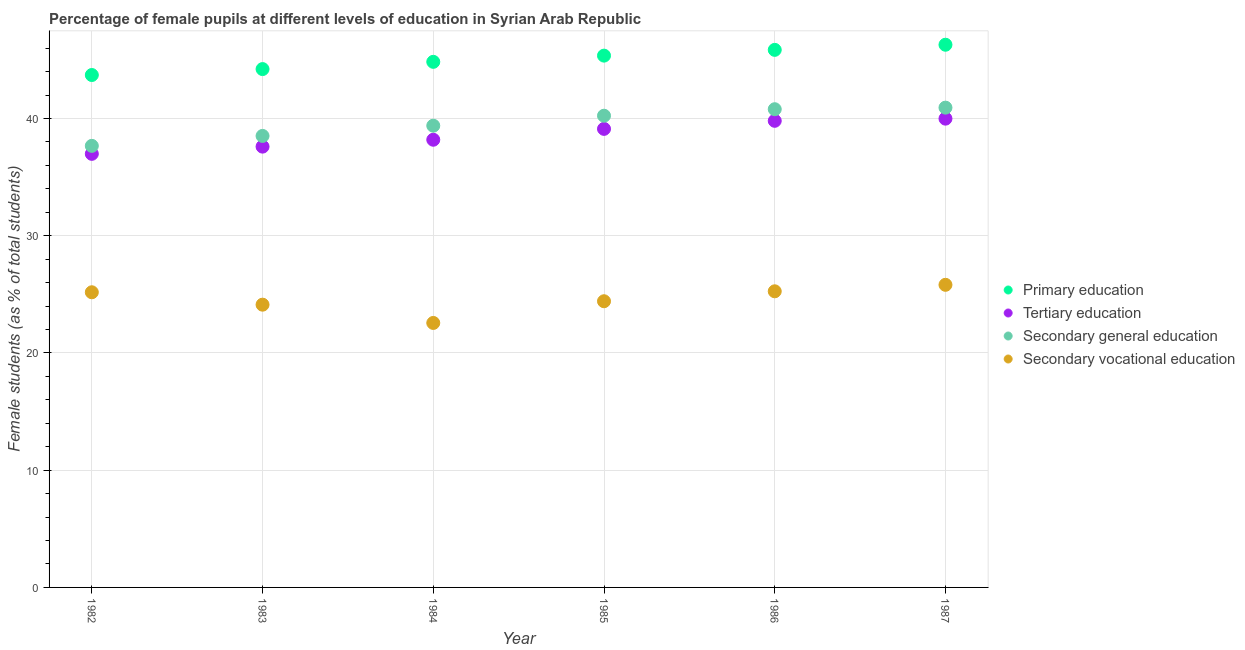Is the number of dotlines equal to the number of legend labels?
Your answer should be very brief. Yes. What is the percentage of female students in tertiary education in 1987?
Give a very brief answer. 39.99. Across all years, what is the maximum percentage of female students in primary education?
Your answer should be very brief. 46.3. Across all years, what is the minimum percentage of female students in secondary education?
Keep it short and to the point. 37.67. In which year was the percentage of female students in primary education maximum?
Provide a succinct answer. 1987. What is the total percentage of female students in secondary vocational education in the graph?
Your answer should be compact. 147.36. What is the difference between the percentage of female students in secondary vocational education in 1982 and that in 1986?
Your answer should be compact. -0.08. What is the difference between the percentage of female students in primary education in 1983 and the percentage of female students in secondary education in 1984?
Your response must be concise. 4.83. What is the average percentage of female students in secondary education per year?
Keep it short and to the point. 39.59. In the year 1985, what is the difference between the percentage of female students in tertiary education and percentage of female students in secondary education?
Give a very brief answer. -1.12. What is the ratio of the percentage of female students in primary education in 1984 to that in 1987?
Your response must be concise. 0.97. Is the percentage of female students in primary education in 1983 less than that in 1986?
Make the answer very short. Yes. Is the difference between the percentage of female students in secondary education in 1982 and 1985 greater than the difference between the percentage of female students in primary education in 1982 and 1985?
Make the answer very short. No. What is the difference between the highest and the second highest percentage of female students in secondary vocational education?
Provide a short and direct response. 0.55. What is the difference between the highest and the lowest percentage of female students in primary education?
Give a very brief answer. 2.58. Is the sum of the percentage of female students in secondary education in 1984 and 1985 greater than the maximum percentage of female students in tertiary education across all years?
Offer a very short reply. Yes. Is it the case that in every year, the sum of the percentage of female students in primary education and percentage of female students in secondary vocational education is greater than the sum of percentage of female students in secondary education and percentage of female students in tertiary education?
Offer a terse response. No. Is it the case that in every year, the sum of the percentage of female students in primary education and percentage of female students in tertiary education is greater than the percentage of female students in secondary education?
Provide a succinct answer. Yes. Does the percentage of female students in tertiary education monotonically increase over the years?
Give a very brief answer. Yes. How many dotlines are there?
Offer a very short reply. 4. How many years are there in the graph?
Offer a very short reply. 6. Does the graph contain grids?
Provide a succinct answer. Yes. How many legend labels are there?
Your answer should be compact. 4. What is the title of the graph?
Make the answer very short. Percentage of female pupils at different levels of education in Syrian Arab Republic. What is the label or title of the Y-axis?
Provide a succinct answer. Female students (as % of total students). What is the Female students (as % of total students) of Primary education in 1982?
Provide a succinct answer. 43.71. What is the Female students (as % of total students) in Tertiary education in 1982?
Your answer should be compact. 36.99. What is the Female students (as % of total students) of Secondary general education in 1982?
Your answer should be very brief. 37.67. What is the Female students (as % of total students) in Secondary vocational education in 1982?
Keep it short and to the point. 25.18. What is the Female students (as % of total students) of Primary education in 1983?
Your answer should be very brief. 44.22. What is the Female students (as % of total students) in Tertiary education in 1983?
Ensure brevity in your answer.  37.6. What is the Female students (as % of total students) in Secondary general education in 1983?
Offer a terse response. 38.52. What is the Female students (as % of total students) of Secondary vocational education in 1983?
Give a very brief answer. 24.12. What is the Female students (as % of total students) of Primary education in 1984?
Your response must be concise. 44.84. What is the Female students (as % of total students) of Tertiary education in 1984?
Your response must be concise. 38.19. What is the Female students (as % of total students) of Secondary general education in 1984?
Give a very brief answer. 39.39. What is the Female students (as % of total students) of Secondary vocational education in 1984?
Your answer should be very brief. 22.56. What is the Female students (as % of total students) of Primary education in 1985?
Your response must be concise. 45.37. What is the Female students (as % of total students) of Tertiary education in 1985?
Your answer should be very brief. 39.12. What is the Female students (as % of total students) in Secondary general education in 1985?
Keep it short and to the point. 40.24. What is the Female students (as % of total students) in Secondary vocational education in 1985?
Ensure brevity in your answer.  24.41. What is the Female students (as % of total students) in Primary education in 1986?
Provide a short and direct response. 45.86. What is the Female students (as % of total students) in Tertiary education in 1986?
Provide a succinct answer. 39.81. What is the Female students (as % of total students) of Secondary general education in 1986?
Offer a terse response. 40.8. What is the Female students (as % of total students) of Secondary vocational education in 1986?
Keep it short and to the point. 25.26. What is the Female students (as % of total students) in Primary education in 1987?
Your answer should be compact. 46.3. What is the Female students (as % of total students) in Tertiary education in 1987?
Provide a succinct answer. 39.99. What is the Female students (as % of total students) in Secondary general education in 1987?
Your answer should be compact. 40.93. What is the Female students (as % of total students) of Secondary vocational education in 1987?
Make the answer very short. 25.82. Across all years, what is the maximum Female students (as % of total students) in Primary education?
Ensure brevity in your answer.  46.3. Across all years, what is the maximum Female students (as % of total students) of Tertiary education?
Offer a terse response. 39.99. Across all years, what is the maximum Female students (as % of total students) in Secondary general education?
Provide a succinct answer. 40.93. Across all years, what is the maximum Female students (as % of total students) in Secondary vocational education?
Give a very brief answer. 25.82. Across all years, what is the minimum Female students (as % of total students) of Primary education?
Give a very brief answer. 43.71. Across all years, what is the minimum Female students (as % of total students) of Tertiary education?
Offer a terse response. 36.99. Across all years, what is the minimum Female students (as % of total students) of Secondary general education?
Provide a short and direct response. 37.67. Across all years, what is the minimum Female students (as % of total students) in Secondary vocational education?
Offer a terse response. 22.56. What is the total Female students (as % of total students) in Primary education in the graph?
Your answer should be compact. 270.29. What is the total Female students (as % of total students) in Tertiary education in the graph?
Your answer should be very brief. 231.7. What is the total Female students (as % of total students) of Secondary general education in the graph?
Give a very brief answer. 237.54. What is the total Female students (as % of total students) of Secondary vocational education in the graph?
Offer a terse response. 147.36. What is the difference between the Female students (as % of total students) of Primary education in 1982 and that in 1983?
Give a very brief answer. -0.51. What is the difference between the Female students (as % of total students) in Tertiary education in 1982 and that in 1983?
Offer a terse response. -0.62. What is the difference between the Female students (as % of total students) of Secondary general education in 1982 and that in 1983?
Offer a terse response. -0.85. What is the difference between the Female students (as % of total students) of Secondary vocational education in 1982 and that in 1983?
Provide a succinct answer. 1.06. What is the difference between the Female students (as % of total students) in Primary education in 1982 and that in 1984?
Your response must be concise. -1.12. What is the difference between the Female students (as % of total students) of Tertiary education in 1982 and that in 1984?
Offer a terse response. -1.2. What is the difference between the Female students (as % of total students) in Secondary general education in 1982 and that in 1984?
Your answer should be very brief. -1.72. What is the difference between the Female students (as % of total students) of Secondary vocational education in 1982 and that in 1984?
Make the answer very short. 2.62. What is the difference between the Female students (as % of total students) of Primary education in 1982 and that in 1985?
Provide a short and direct response. -1.65. What is the difference between the Female students (as % of total students) of Tertiary education in 1982 and that in 1985?
Your answer should be very brief. -2.13. What is the difference between the Female students (as % of total students) of Secondary general education in 1982 and that in 1985?
Offer a very short reply. -2.57. What is the difference between the Female students (as % of total students) of Secondary vocational education in 1982 and that in 1985?
Your answer should be very brief. 0.77. What is the difference between the Female students (as % of total students) of Primary education in 1982 and that in 1986?
Provide a short and direct response. -2.15. What is the difference between the Female students (as % of total students) of Tertiary education in 1982 and that in 1986?
Your answer should be compact. -2.82. What is the difference between the Female students (as % of total students) in Secondary general education in 1982 and that in 1986?
Offer a terse response. -3.13. What is the difference between the Female students (as % of total students) of Secondary vocational education in 1982 and that in 1986?
Provide a succinct answer. -0.08. What is the difference between the Female students (as % of total students) of Primary education in 1982 and that in 1987?
Provide a short and direct response. -2.58. What is the difference between the Female students (as % of total students) in Tertiary education in 1982 and that in 1987?
Offer a very short reply. -3. What is the difference between the Female students (as % of total students) in Secondary general education in 1982 and that in 1987?
Keep it short and to the point. -3.26. What is the difference between the Female students (as % of total students) in Secondary vocational education in 1982 and that in 1987?
Offer a very short reply. -0.64. What is the difference between the Female students (as % of total students) of Primary education in 1983 and that in 1984?
Give a very brief answer. -0.62. What is the difference between the Female students (as % of total students) in Tertiary education in 1983 and that in 1984?
Provide a succinct answer. -0.59. What is the difference between the Female students (as % of total students) in Secondary general education in 1983 and that in 1984?
Provide a short and direct response. -0.87. What is the difference between the Female students (as % of total students) in Secondary vocational education in 1983 and that in 1984?
Make the answer very short. 1.56. What is the difference between the Female students (as % of total students) in Primary education in 1983 and that in 1985?
Your answer should be very brief. -1.15. What is the difference between the Female students (as % of total students) of Tertiary education in 1983 and that in 1985?
Your response must be concise. -1.51. What is the difference between the Female students (as % of total students) of Secondary general education in 1983 and that in 1985?
Your answer should be compact. -1.72. What is the difference between the Female students (as % of total students) of Secondary vocational education in 1983 and that in 1985?
Make the answer very short. -0.29. What is the difference between the Female students (as % of total students) of Primary education in 1983 and that in 1986?
Your answer should be compact. -1.64. What is the difference between the Female students (as % of total students) in Tertiary education in 1983 and that in 1986?
Give a very brief answer. -2.2. What is the difference between the Female students (as % of total students) of Secondary general education in 1983 and that in 1986?
Provide a succinct answer. -2.28. What is the difference between the Female students (as % of total students) of Secondary vocational education in 1983 and that in 1986?
Offer a terse response. -1.14. What is the difference between the Female students (as % of total students) in Primary education in 1983 and that in 1987?
Provide a succinct answer. -2.08. What is the difference between the Female students (as % of total students) in Tertiary education in 1983 and that in 1987?
Make the answer very short. -2.39. What is the difference between the Female students (as % of total students) of Secondary general education in 1983 and that in 1987?
Give a very brief answer. -2.41. What is the difference between the Female students (as % of total students) of Secondary vocational education in 1983 and that in 1987?
Give a very brief answer. -1.69. What is the difference between the Female students (as % of total students) of Primary education in 1984 and that in 1985?
Provide a succinct answer. -0.53. What is the difference between the Female students (as % of total students) of Tertiary education in 1984 and that in 1985?
Make the answer very short. -0.93. What is the difference between the Female students (as % of total students) in Secondary general education in 1984 and that in 1985?
Your answer should be compact. -0.85. What is the difference between the Female students (as % of total students) in Secondary vocational education in 1984 and that in 1985?
Provide a short and direct response. -1.85. What is the difference between the Female students (as % of total students) in Primary education in 1984 and that in 1986?
Your answer should be compact. -1.02. What is the difference between the Female students (as % of total students) in Tertiary education in 1984 and that in 1986?
Your response must be concise. -1.61. What is the difference between the Female students (as % of total students) in Secondary general education in 1984 and that in 1986?
Your answer should be very brief. -1.41. What is the difference between the Female students (as % of total students) of Secondary vocational education in 1984 and that in 1986?
Keep it short and to the point. -2.7. What is the difference between the Female students (as % of total students) in Primary education in 1984 and that in 1987?
Make the answer very short. -1.46. What is the difference between the Female students (as % of total students) of Tertiary education in 1984 and that in 1987?
Make the answer very short. -1.8. What is the difference between the Female students (as % of total students) of Secondary general education in 1984 and that in 1987?
Make the answer very short. -1.54. What is the difference between the Female students (as % of total students) in Secondary vocational education in 1984 and that in 1987?
Offer a very short reply. -3.25. What is the difference between the Female students (as % of total students) of Primary education in 1985 and that in 1986?
Your response must be concise. -0.49. What is the difference between the Female students (as % of total students) in Tertiary education in 1985 and that in 1986?
Provide a short and direct response. -0.69. What is the difference between the Female students (as % of total students) of Secondary general education in 1985 and that in 1986?
Offer a terse response. -0.55. What is the difference between the Female students (as % of total students) of Secondary vocational education in 1985 and that in 1986?
Keep it short and to the point. -0.85. What is the difference between the Female students (as % of total students) of Primary education in 1985 and that in 1987?
Your answer should be very brief. -0.93. What is the difference between the Female students (as % of total students) of Tertiary education in 1985 and that in 1987?
Keep it short and to the point. -0.87. What is the difference between the Female students (as % of total students) of Secondary general education in 1985 and that in 1987?
Provide a short and direct response. -0.69. What is the difference between the Female students (as % of total students) in Secondary vocational education in 1985 and that in 1987?
Ensure brevity in your answer.  -1.4. What is the difference between the Female students (as % of total students) in Primary education in 1986 and that in 1987?
Keep it short and to the point. -0.44. What is the difference between the Female students (as % of total students) in Tertiary education in 1986 and that in 1987?
Offer a very short reply. -0.18. What is the difference between the Female students (as % of total students) of Secondary general education in 1986 and that in 1987?
Keep it short and to the point. -0.13. What is the difference between the Female students (as % of total students) of Secondary vocational education in 1986 and that in 1987?
Provide a short and direct response. -0.55. What is the difference between the Female students (as % of total students) of Primary education in 1982 and the Female students (as % of total students) of Tertiary education in 1983?
Your answer should be compact. 6.11. What is the difference between the Female students (as % of total students) in Primary education in 1982 and the Female students (as % of total students) in Secondary general education in 1983?
Offer a very short reply. 5.2. What is the difference between the Female students (as % of total students) of Primary education in 1982 and the Female students (as % of total students) of Secondary vocational education in 1983?
Your answer should be compact. 19.59. What is the difference between the Female students (as % of total students) of Tertiary education in 1982 and the Female students (as % of total students) of Secondary general education in 1983?
Your answer should be very brief. -1.53. What is the difference between the Female students (as % of total students) in Tertiary education in 1982 and the Female students (as % of total students) in Secondary vocational education in 1983?
Provide a short and direct response. 12.87. What is the difference between the Female students (as % of total students) in Secondary general education in 1982 and the Female students (as % of total students) in Secondary vocational education in 1983?
Keep it short and to the point. 13.55. What is the difference between the Female students (as % of total students) in Primary education in 1982 and the Female students (as % of total students) in Tertiary education in 1984?
Provide a succinct answer. 5.52. What is the difference between the Female students (as % of total students) in Primary education in 1982 and the Female students (as % of total students) in Secondary general education in 1984?
Your answer should be very brief. 4.32. What is the difference between the Female students (as % of total students) in Primary education in 1982 and the Female students (as % of total students) in Secondary vocational education in 1984?
Provide a short and direct response. 21.15. What is the difference between the Female students (as % of total students) of Tertiary education in 1982 and the Female students (as % of total students) of Secondary general education in 1984?
Your answer should be very brief. -2.4. What is the difference between the Female students (as % of total students) in Tertiary education in 1982 and the Female students (as % of total students) in Secondary vocational education in 1984?
Make the answer very short. 14.43. What is the difference between the Female students (as % of total students) in Secondary general education in 1982 and the Female students (as % of total students) in Secondary vocational education in 1984?
Your response must be concise. 15.11. What is the difference between the Female students (as % of total students) of Primary education in 1982 and the Female students (as % of total students) of Tertiary education in 1985?
Ensure brevity in your answer.  4.6. What is the difference between the Female students (as % of total students) of Primary education in 1982 and the Female students (as % of total students) of Secondary general education in 1985?
Your answer should be very brief. 3.47. What is the difference between the Female students (as % of total students) of Primary education in 1982 and the Female students (as % of total students) of Secondary vocational education in 1985?
Your answer should be very brief. 19.3. What is the difference between the Female students (as % of total students) of Tertiary education in 1982 and the Female students (as % of total students) of Secondary general education in 1985?
Ensure brevity in your answer.  -3.25. What is the difference between the Female students (as % of total students) of Tertiary education in 1982 and the Female students (as % of total students) of Secondary vocational education in 1985?
Offer a very short reply. 12.57. What is the difference between the Female students (as % of total students) of Secondary general education in 1982 and the Female students (as % of total students) of Secondary vocational education in 1985?
Provide a succinct answer. 13.26. What is the difference between the Female students (as % of total students) of Primary education in 1982 and the Female students (as % of total students) of Tertiary education in 1986?
Offer a very short reply. 3.91. What is the difference between the Female students (as % of total students) in Primary education in 1982 and the Female students (as % of total students) in Secondary general education in 1986?
Keep it short and to the point. 2.92. What is the difference between the Female students (as % of total students) of Primary education in 1982 and the Female students (as % of total students) of Secondary vocational education in 1986?
Offer a very short reply. 18.45. What is the difference between the Female students (as % of total students) in Tertiary education in 1982 and the Female students (as % of total students) in Secondary general education in 1986?
Offer a terse response. -3.81. What is the difference between the Female students (as % of total students) in Tertiary education in 1982 and the Female students (as % of total students) in Secondary vocational education in 1986?
Offer a terse response. 11.73. What is the difference between the Female students (as % of total students) of Secondary general education in 1982 and the Female students (as % of total students) of Secondary vocational education in 1986?
Offer a terse response. 12.41. What is the difference between the Female students (as % of total students) of Primary education in 1982 and the Female students (as % of total students) of Tertiary education in 1987?
Make the answer very short. 3.72. What is the difference between the Female students (as % of total students) of Primary education in 1982 and the Female students (as % of total students) of Secondary general education in 1987?
Ensure brevity in your answer.  2.78. What is the difference between the Female students (as % of total students) of Primary education in 1982 and the Female students (as % of total students) of Secondary vocational education in 1987?
Provide a succinct answer. 17.9. What is the difference between the Female students (as % of total students) in Tertiary education in 1982 and the Female students (as % of total students) in Secondary general education in 1987?
Your response must be concise. -3.94. What is the difference between the Female students (as % of total students) of Tertiary education in 1982 and the Female students (as % of total students) of Secondary vocational education in 1987?
Keep it short and to the point. 11.17. What is the difference between the Female students (as % of total students) in Secondary general education in 1982 and the Female students (as % of total students) in Secondary vocational education in 1987?
Offer a very short reply. 11.85. What is the difference between the Female students (as % of total students) of Primary education in 1983 and the Female students (as % of total students) of Tertiary education in 1984?
Make the answer very short. 6.03. What is the difference between the Female students (as % of total students) of Primary education in 1983 and the Female students (as % of total students) of Secondary general education in 1984?
Provide a short and direct response. 4.83. What is the difference between the Female students (as % of total students) of Primary education in 1983 and the Female students (as % of total students) of Secondary vocational education in 1984?
Offer a very short reply. 21.66. What is the difference between the Female students (as % of total students) of Tertiary education in 1983 and the Female students (as % of total students) of Secondary general education in 1984?
Make the answer very short. -1.79. What is the difference between the Female students (as % of total students) of Tertiary education in 1983 and the Female students (as % of total students) of Secondary vocational education in 1984?
Offer a very short reply. 15.04. What is the difference between the Female students (as % of total students) in Secondary general education in 1983 and the Female students (as % of total students) in Secondary vocational education in 1984?
Make the answer very short. 15.95. What is the difference between the Female students (as % of total students) of Primary education in 1983 and the Female students (as % of total students) of Tertiary education in 1985?
Keep it short and to the point. 5.1. What is the difference between the Female students (as % of total students) in Primary education in 1983 and the Female students (as % of total students) in Secondary general education in 1985?
Offer a terse response. 3.98. What is the difference between the Female students (as % of total students) of Primary education in 1983 and the Female students (as % of total students) of Secondary vocational education in 1985?
Your answer should be very brief. 19.81. What is the difference between the Female students (as % of total students) of Tertiary education in 1983 and the Female students (as % of total students) of Secondary general education in 1985?
Your answer should be very brief. -2.64. What is the difference between the Female students (as % of total students) in Tertiary education in 1983 and the Female students (as % of total students) in Secondary vocational education in 1985?
Your response must be concise. 13.19. What is the difference between the Female students (as % of total students) in Secondary general education in 1983 and the Female students (as % of total students) in Secondary vocational education in 1985?
Your answer should be very brief. 14.1. What is the difference between the Female students (as % of total students) in Primary education in 1983 and the Female students (as % of total students) in Tertiary education in 1986?
Give a very brief answer. 4.41. What is the difference between the Female students (as % of total students) of Primary education in 1983 and the Female students (as % of total students) of Secondary general education in 1986?
Provide a succinct answer. 3.42. What is the difference between the Female students (as % of total students) of Primary education in 1983 and the Female students (as % of total students) of Secondary vocational education in 1986?
Offer a very short reply. 18.96. What is the difference between the Female students (as % of total students) in Tertiary education in 1983 and the Female students (as % of total students) in Secondary general education in 1986?
Offer a terse response. -3.19. What is the difference between the Female students (as % of total students) in Tertiary education in 1983 and the Female students (as % of total students) in Secondary vocational education in 1986?
Your answer should be very brief. 12.34. What is the difference between the Female students (as % of total students) in Secondary general education in 1983 and the Female students (as % of total students) in Secondary vocational education in 1986?
Offer a terse response. 13.25. What is the difference between the Female students (as % of total students) of Primary education in 1983 and the Female students (as % of total students) of Tertiary education in 1987?
Keep it short and to the point. 4.23. What is the difference between the Female students (as % of total students) of Primary education in 1983 and the Female students (as % of total students) of Secondary general education in 1987?
Your response must be concise. 3.29. What is the difference between the Female students (as % of total students) in Primary education in 1983 and the Female students (as % of total students) in Secondary vocational education in 1987?
Your response must be concise. 18.4. What is the difference between the Female students (as % of total students) of Tertiary education in 1983 and the Female students (as % of total students) of Secondary general education in 1987?
Give a very brief answer. -3.33. What is the difference between the Female students (as % of total students) of Tertiary education in 1983 and the Female students (as % of total students) of Secondary vocational education in 1987?
Ensure brevity in your answer.  11.79. What is the difference between the Female students (as % of total students) of Secondary general education in 1983 and the Female students (as % of total students) of Secondary vocational education in 1987?
Offer a terse response. 12.7. What is the difference between the Female students (as % of total students) in Primary education in 1984 and the Female students (as % of total students) in Tertiary education in 1985?
Offer a terse response. 5.72. What is the difference between the Female students (as % of total students) of Primary education in 1984 and the Female students (as % of total students) of Secondary general education in 1985?
Ensure brevity in your answer.  4.6. What is the difference between the Female students (as % of total students) of Primary education in 1984 and the Female students (as % of total students) of Secondary vocational education in 1985?
Your response must be concise. 20.42. What is the difference between the Female students (as % of total students) in Tertiary education in 1984 and the Female students (as % of total students) in Secondary general education in 1985?
Keep it short and to the point. -2.05. What is the difference between the Female students (as % of total students) in Tertiary education in 1984 and the Female students (as % of total students) in Secondary vocational education in 1985?
Give a very brief answer. 13.78. What is the difference between the Female students (as % of total students) of Secondary general education in 1984 and the Female students (as % of total students) of Secondary vocational education in 1985?
Your answer should be compact. 14.98. What is the difference between the Female students (as % of total students) in Primary education in 1984 and the Female students (as % of total students) in Tertiary education in 1986?
Offer a very short reply. 5.03. What is the difference between the Female students (as % of total students) of Primary education in 1984 and the Female students (as % of total students) of Secondary general education in 1986?
Provide a succinct answer. 4.04. What is the difference between the Female students (as % of total students) in Primary education in 1984 and the Female students (as % of total students) in Secondary vocational education in 1986?
Offer a terse response. 19.58. What is the difference between the Female students (as % of total students) in Tertiary education in 1984 and the Female students (as % of total students) in Secondary general education in 1986?
Offer a terse response. -2.6. What is the difference between the Female students (as % of total students) in Tertiary education in 1984 and the Female students (as % of total students) in Secondary vocational education in 1986?
Keep it short and to the point. 12.93. What is the difference between the Female students (as % of total students) in Secondary general education in 1984 and the Female students (as % of total students) in Secondary vocational education in 1986?
Provide a short and direct response. 14.13. What is the difference between the Female students (as % of total students) of Primary education in 1984 and the Female students (as % of total students) of Tertiary education in 1987?
Your answer should be compact. 4.85. What is the difference between the Female students (as % of total students) in Primary education in 1984 and the Female students (as % of total students) in Secondary general education in 1987?
Provide a short and direct response. 3.91. What is the difference between the Female students (as % of total students) in Primary education in 1984 and the Female students (as % of total students) in Secondary vocational education in 1987?
Make the answer very short. 19.02. What is the difference between the Female students (as % of total students) of Tertiary education in 1984 and the Female students (as % of total students) of Secondary general education in 1987?
Give a very brief answer. -2.74. What is the difference between the Female students (as % of total students) of Tertiary education in 1984 and the Female students (as % of total students) of Secondary vocational education in 1987?
Your answer should be very brief. 12.38. What is the difference between the Female students (as % of total students) in Secondary general education in 1984 and the Female students (as % of total students) in Secondary vocational education in 1987?
Your answer should be compact. 13.57. What is the difference between the Female students (as % of total students) in Primary education in 1985 and the Female students (as % of total students) in Tertiary education in 1986?
Offer a terse response. 5.56. What is the difference between the Female students (as % of total students) of Primary education in 1985 and the Female students (as % of total students) of Secondary general education in 1986?
Your response must be concise. 4.57. What is the difference between the Female students (as % of total students) of Primary education in 1985 and the Female students (as % of total students) of Secondary vocational education in 1986?
Your answer should be compact. 20.1. What is the difference between the Female students (as % of total students) of Tertiary education in 1985 and the Female students (as % of total students) of Secondary general education in 1986?
Give a very brief answer. -1.68. What is the difference between the Female students (as % of total students) of Tertiary education in 1985 and the Female students (as % of total students) of Secondary vocational education in 1986?
Your answer should be compact. 13.86. What is the difference between the Female students (as % of total students) in Secondary general education in 1985 and the Female students (as % of total students) in Secondary vocational education in 1986?
Provide a short and direct response. 14.98. What is the difference between the Female students (as % of total students) in Primary education in 1985 and the Female students (as % of total students) in Tertiary education in 1987?
Ensure brevity in your answer.  5.38. What is the difference between the Female students (as % of total students) of Primary education in 1985 and the Female students (as % of total students) of Secondary general education in 1987?
Provide a short and direct response. 4.44. What is the difference between the Female students (as % of total students) in Primary education in 1985 and the Female students (as % of total students) in Secondary vocational education in 1987?
Offer a very short reply. 19.55. What is the difference between the Female students (as % of total students) in Tertiary education in 1985 and the Female students (as % of total students) in Secondary general education in 1987?
Your response must be concise. -1.81. What is the difference between the Female students (as % of total students) of Tertiary education in 1985 and the Female students (as % of total students) of Secondary vocational education in 1987?
Your response must be concise. 13.3. What is the difference between the Female students (as % of total students) in Secondary general education in 1985 and the Female students (as % of total students) in Secondary vocational education in 1987?
Offer a terse response. 14.43. What is the difference between the Female students (as % of total students) in Primary education in 1986 and the Female students (as % of total students) in Tertiary education in 1987?
Give a very brief answer. 5.87. What is the difference between the Female students (as % of total students) of Primary education in 1986 and the Female students (as % of total students) of Secondary general education in 1987?
Your answer should be compact. 4.93. What is the difference between the Female students (as % of total students) in Primary education in 1986 and the Female students (as % of total students) in Secondary vocational education in 1987?
Make the answer very short. 20.04. What is the difference between the Female students (as % of total students) of Tertiary education in 1986 and the Female students (as % of total students) of Secondary general education in 1987?
Your answer should be compact. -1.12. What is the difference between the Female students (as % of total students) of Tertiary education in 1986 and the Female students (as % of total students) of Secondary vocational education in 1987?
Your answer should be very brief. 13.99. What is the difference between the Female students (as % of total students) of Secondary general education in 1986 and the Female students (as % of total students) of Secondary vocational education in 1987?
Provide a succinct answer. 14.98. What is the average Female students (as % of total students) in Primary education per year?
Your response must be concise. 45.05. What is the average Female students (as % of total students) in Tertiary education per year?
Ensure brevity in your answer.  38.62. What is the average Female students (as % of total students) in Secondary general education per year?
Give a very brief answer. 39.59. What is the average Female students (as % of total students) in Secondary vocational education per year?
Provide a succinct answer. 24.56. In the year 1982, what is the difference between the Female students (as % of total students) of Primary education and Female students (as % of total students) of Tertiary education?
Your answer should be very brief. 6.72. In the year 1982, what is the difference between the Female students (as % of total students) of Primary education and Female students (as % of total students) of Secondary general education?
Offer a terse response. 6.04. In the year 1982, what is the difference between the Female students (as % of total students) in Primary education and Female students (as % of total students) in Secondary vocational education?
Keep it short and to the point. 18.53. In the year 1982, what is the difference between the Female students (as % of total students) in Tertiary education and Female students (as % of total students) in Secondary general education?
Ensure brevity in your answer.  -0.68. In the year 1982, what is the difference between the Female students (as % of total students) in Tertiary education and Female students (as % of total students) in Secondary vocational education?
Your answer should be very brief. 11.81. In the year 1982, what is the difference between the Female students (as % of total students) in Secondary general education and Female students (as % of total students) in Secondary vocational education?
Your answer should be very brief. 12.49. In the year 1983, what is the difference between the Female students (as % of total students) in Primary education and Female students (as % of total students) in Tertiary education?
Provide a short and direct response. 6.62. In the year 1983, what is the difference between the Female students (as % of total students) in Primary education and Female students (as % of total students) in Secondary general education?
Make the answer very short. 5.7. In the year 1983, what is the difference between the Female students (as % of total students) in Primary education and Female students (as % of total students) in Secondary vocational education?
Offer a terse response. 20.1. In the year 1983, what is the difference between the Female students (as % of total students) in Tertiary education and Female students (as % of total students) in Secondary general education?
Make the answer very short. -0.91. In the year 1983, what is the difference between the Female students (as % of total students) in Tertiary education and Female students (as % of total students) in Secondary vocational education?
Offer a terse response. 13.48. In the year 1983, what is the difference between the Female students (as % of total students) in Secondary general education and Female students (as % of total students) in Secondary vocational education?
Make the answer very short. 14.4. In the year 1984, what is the difference between the Female students (as % of total students) of Primary education and Female students (as % of total students) of Tertiary education?
Offer a terse response. 6.65. In the year 1984, what is the difference between the Female students (as % of total students) in Primary education and Female students (as % of total students) in Secondary general education?
Keep it short and to the point. 5.45. In the year 1984, what is the difference between the Female students (as % of total students) in Primary education and Female students (as % of total students) in Secondary vocational education?
Give a very brief answer. 22.27. In the year 1984, what is the difference between the Female students (as % of total students) of Tertiary education and Female students (as % of total students) of Secondary general education?
Keep it short and to the point. -1.2. In the year 1984, what is the difference between the Female students (as % of total students) of Tertiary education and Female students (as % of total students) of Secondary vocational education?
Your answer should be very brief. 15.63. In the year 1984, what is the difference between the Female students (as % of total students) of Secondary general education and Female students (as % of total students) of Secondary vocational education?
Your response must be concise. 16.83. In the year 1985, what is the difference between the Female students (as % of total students) of Primary education and Female students (as % of total students) of Tertiary education?
Offer a very short reply. 6.25. In the year 1985, what is the difference between the Female students (as % of total students) in Primary education and Female students (as % of total students) in Secondary general education?
Make the answer very short. 5.13. In the year 1985, what is the difference between the Female students (as % of total students) of Primary education and Female students (as % of total students) of Secondary vocational education?
Make the answer very short. 20.95. In the year 1985, what is the difference between the Female students (as % of total students) in Tertiary education and Female students (as % of total students) in Secondary general education?
Your response must be concise. -1.12. In the year 1985, what is the difference between the Female students (as % of total students) of Tertiary education and Female students (as % of total students) of Secondary vocational education?
Make the answer very short. 14.7. In the year 1985, what is the difference between the Female students (as % of total students) in Secondary general education and Female students (as % of total students) in Secondary vocational education?
Offer a very short reply. 15.83. In the year 1986, what is the difference between the Female students (as % of total students) of Primary education and Female students (as % of total students) of Tertiary education?
Offer a very short reply. 6.05. In the year 1986, what is the difference between the Female students (as % of total students) of Primary education and Female students (as % of total students) of Secondary general education?
Your answer should be very brief. 5.06. In the year 1986, what is the difference between the Female students (as % of total students) in Primary education and Female students (as % of total students) in Secondary vocational education?
Offer a very short reply. 20.6. In the year 1986, what is the difference between the Female students (as % of total students) in Tertiary education and Female students (as % of total students) in Secondary general education?
Your answer should be compact. -0.99. In the year 1986, what is the difference between the Female students (as % of total students) in Tertiary education and Female students (as % of total students) in Secondary vocational education?
Make the answer very short. 14.54. In the year 1986, what is the difference between the Female students (as % of total students) of Secondary general education and Female students (as % of total students) of Secondary vocational education?
Provide a succinct answer. 15.53. In the year 1987, what is the difference between the Female students (as % of total students) in Primary education and Female students (as % of total students) in Tertiary education?
Offer a very short reply. 6.31. In the year 1987, what is the difference between the Female students (as % of total students) in Primary education and Female students (as % of total students) in Secondary general education?
Provide a short and direct response. 5.37. In the year 1987, what is the difference between the Female students (as % of total students) of Primary education and Female students (as % of total students) of Secondary vocational education?
Keep it short and to the point. 20.48. In the year 1987, what is the difference between the Female students (as % of total students) of Tertiary education and Female students (as % of total students) of Secondary general education?
Keep it short and to the point. -0.94. In the year 1987, what is the difference between the Female students (as % of total students) of Tertiary education and Female students (as % of total students) of Secondary vocational education?
Your answer should be compact. 14.18. In the year 1987, what is the difference between the Female students (as % of total students) in Secondary general education and Female students (as % of total students) in Secondary vocational education?
Provide a short and direct response. 15.11. What is the ratio of the Female students (as % of total students) in Tertiary education in 1982 to that in 1983?
Provide a short and direct response. 0.98. What is the ratio of the Female students (as % of total students) in Secondary general education in 1982 to that in 1983?
Give a very brief answer. 0.98. What is the ratio of the Female students (as % of total students) of Secondary vocational education in 1982 to that in 1983?
Ensure brevity in your answer.  1.04. What is the ratio of the Female students (as % of total students) in Primary education in 1982 to that in 1984?
Give a very brief answer. 0.97. What is the ratio of the Female students (as % of total students) in Tertiary education in 1982 to that in 1984?
Your response must be concise. 0.97. What is the ratio of the Female students (as % of total students) of Secondary general education in 1982 to that in 1984?
Keep it short and to the point. 0.96. What is the ratio of the Female students (as % of total students) in Secondary vocational education in 1982 to that in 1984?
Offer a terse response. 1.12. What is the ratio of the Female students (as % of total students) in Primary education in 1982 to that in 1985?
Give a very brief answer. 0.96. What is the ratio of the Female students (as % of total students) in Tertiary education in 1982 to that in 1985?
Your response must be concise. 0.95. What is the ratio of the Female students (as % of total students) of Secondary general education in 1982 to that in 1985?
Offer a very short reply. 0.94. What is the ratio of the Female students (as % of total students) in Secondary vocational education in 1982 to that in 1985?
Your answer should be very brief. 1.03. What is the ratio of the Female students (as % of total students) of Primary education in 1982 to that in 1986?
Offer a terse response. 0.95. What is the ratio of the Female students (as % of total students) of Tertiary education in 1982 to that in 1986?
Keep it short and to the point. 0.93. What is the ratio of the Female students (as % of total students) in Secondary general education in 1982 to that in 1986?
Offer a terse response. 0.92. What is the ratio of the Female students (as % of total students) in Secondary vocational education in 1982 to that in 1986?
Offer a terse response. 1. What is the ratio of the Female students (as % of total students) of Primary education in 1982 to that in 1987?
Provide a short and direct response. 0.94. What is the ratio of the Female students (as % of total students) of Tertiary education in 1982 to that in 1987?
Your answer should be very brief. 0.92. What is the ratio of the Female students (as % of total students) in Secondary general education in 1982 to that in 1987?
Your response must be concise. 0.92. What is the ratio of the Female students (as % of total students) in Secondary vocational education in 1982 to that in 1987?
Your answer should be very brief. 0.98. What is the ratio of the Female students (as % of total students) of Primary education in 1983 to that in 1984?
Keep it short and to the point. 0.99. What is the ratio of the Female students (as % of total students) in Tertiary education in 1983 to that in 1984?
Offer a very short reply. 0.98. What is the ratio of the Female students (as % of total students) in Secondary general education in 1983 to that in 1984?
Give a very brief answer. 0.98. What is the ratio of the Female students (as % of total students) in Secondary vocational education in 1983 to that in 1984?
Provide a succinct answer. 1.07. What is the ratio of the Female students (as % of total students) of Primary education in 1983 to that in 1985?
Offer a very short reply. 0.97. What is the ratio of the Female students (as % of total students) of Tertiary education in 1983 to that in 1985?
Your response must be concise. 0.96. What is the ratio of the Female students (as % of total students) of Secondary general education in 1983 to that in 1985?
Provide a succinct answer. 0.96. What is the ratio of the Female students (as % of total students) of Primary education in 1983 to that in 1986?
Make the answer very short. 0.96. What is the ratio of the Female students (as % of total students) of Tertiary education in 1983 to that in 1986?
Provide a short and direct response. 0.94. What is the ratio of the Female students (as % of total students) of Secondary general education in 1983 to that in 1986?
Your answer should be very brief. 0.94. What is the ratio of the Female students (as % of total students) of Secondary vocational education in 1983 to that in 1986?
Make the answer very short. 0.95. What is the ratio of the Female students (as % of total students) of Primary education in 1983 to that in 1987?
Give a very brief answer. 0.96. What is the ratio of the Female students (as % of total students) of Tertiary education in 1983 to that in 1987?
Your answer should be very brief. 0.94. What is the ratio of the Female students (as % of total students) of Secondary general education in 1983 to that in 1987?
Your answer should be very brief. 0.94. What is the ratio of the Female students (as % of total students) in Secondary vocational education in 1983 to that in 1987?
Offer a very short reply. 0.93. What is the ratio of the Female students (as % of total students) in Primary education in 1984 to that in 1985?
Provide a succinct answer. 0.99. What is the ratio of the Female students (as % of total students) in Tertiary education in 1984 to that in 1985?
Keep it short and to the point. 0.98. What is the ratio of the Female students (as % of total students) in Secondary general education in 1984 to that in 1985?
Offer a terse response. 0.98. What is the ratio of the Female students (as % of total students) in Secondary vocational education in 1984 to that in 1985?
Offer a very short reply. 0.92. What is the ratio of the Female students (as % of total students) of Primary education in 1984 to that in 1986?
Ensure brevity in your answer.  0.98. What is the ratio of the Female students (as % of total students) in Tertiary education in 1984 to that in 1986?
Your response must be concise. 0.96. What is the ratio of the Female students (as % of total students) of Secondary general education in 1984 to that in 1986?
Your answer should be compact. 0.97. What is the ratio of the Female students (as % of total students) of Secondary vocational education in 1984 to that in 1986?
Give a very brief answer. 0.89. What is the ratio of the Female students (as % of total students) of Primary education in 1984 to that in 1987?
Offer a terse response. 0.97. What is the ratio of the Female students (as % of total students) of Tertiary education in 1984 to that in 1987?
Give a very brief answer. 0.95. What is the ratio of the Female students (as % of total students) in Secondary general education in 1984 to that in 1987?
Your response must be concise. 0.96. What is the ratio of the Female students (as % of total students) of Secondary vocational education in 1984 to that in 1987?
Offer a very short reply. 0.87. What is the ratio of the Female students (as % of total students) in Primary education in 1985 to that in 1986?
Offer a very short reply. 0.99. What is the ratio of the Female students (as % of total students) in Tertiary education in 1985 to that in 1986?
Keep it short and to the point. 0.98. What is the ratio of the Female students (as % of total students) in Secondary general education in 1985 to that in 1986?
Keep it short and to the point. 0.99. What is the ratio of the Female students (as % of total students) of Secondary vocational education in 1985 to that in 1986?
Make the answer very short. 0.97. What is the ratio of the Female students (as % of total students) in Primary education in 1985 to that in 1987?
Keep it short and to the point. 0.98. What is the ratio of the Female students (as % of total students) in Tertiary education in 1985 to that in 1987?
Make the answer very short. 0.98. What is the ratio of the Female students (as % of total students) of Secondary general education in 1985 to that in 1987?
Offer a very short reply. 0.98. What is the ratio of the Female students (as % of total students) of Secondary vocational education in 1985 to that in 1987?
Offer a terse response. 0.95. What is the ratio of the Female students (as % of total students) in Primary education in 1986 to that in 1987?
Your answer should be compact. 0.99. What is the ratio of the Female students (as % of total students) of Secondary vocational education in 1986 to that in 1987?
Your response must be concise. 0.98. What is the difference between the highest and the second highest Female students (as % of total students) in Primary education?
Ensure brevity in your answer.  0.44. What is the difference between the highest and the second highest Female students (as % of total students) in Tertiary education?
Give a very brief answer. 0.18. What is the difference between the highest and the second highest Female students (as % of total students) in Secondary general education?
Your response must be concise. 0.13. What is the difference between the highest and the second highest Female students (as % of total students) of Secondary vocational education?
Your answer should be compact. 0.55. What is the difference between the highest and the lowest Female students (as % of total students) of Primary education?
Offer a very short reply. 2.58. What is the difference between the highest and the lowest Female students (as % of total students) of Tertiary education?
Your answer should be very brief. 3. What is the difference between the highest and the lowest Female students (as % of total students) of Secondary general education?
Make the answer very short. 3.26. What is the difference between the highest and the lowest Female students (as % of total students) in Secondary vocational education?
Provide a succinct answer. 3.25. 